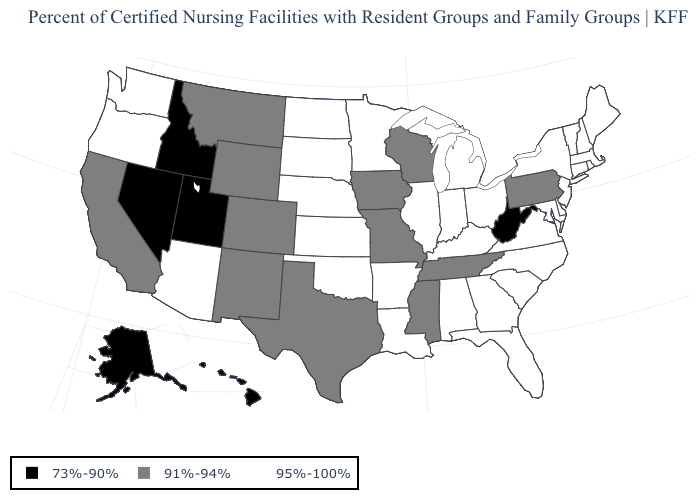Name the states that have a value in the range 73%-90%?
Short answer required. Alaska, Hawaii, Idaho, Nevada, Utah, West Virginia. Does the first symbol in the legend represent the smallest category?
Give a very brief answer. Yes. Among the states that border South Carolina , which have the highest value?
Be succinct. Georgia, North Carolina. Is the legend a continuous bar?
Keep it brief. No. What is the highest value in the Northeast ?
Be succinct. 95%-100%. What is the lowest value in states that border Delaware?
Give a very brief answer. 91%-94%. Among the states that border Arkansas , which have the lowest value?
Give a very brief answer. Mississippi, Missouri, Tennessee, Texas. Which states have the lowest value in the USA?
Short answer required. Alaska, Hawaii, Idaho, Nevada, Utah, West Virginia. Does Michigan have the lowest value in the USA?
Be succinct. No. Name the states that have a value in the range 91%-94%?
Quick response, please. California, Colorado, Iowa, Mississippi, Missouri, Montana, New Mexico, Pennsylvania, Tennessee, Texas, Wisconsin, Wyoming. What is the value of Iowa?
Answer briefly. 91%-94%. What is the highest value in the West ?
Be succinct. 95%-100%. Which states have the lowest value in the USA?
Give a very brief answer. Alaska, Hawaii, Idaho, Nevada, Utah, West Virginia. What is the value of Oregon?
Short answer required. 95%-100%. 